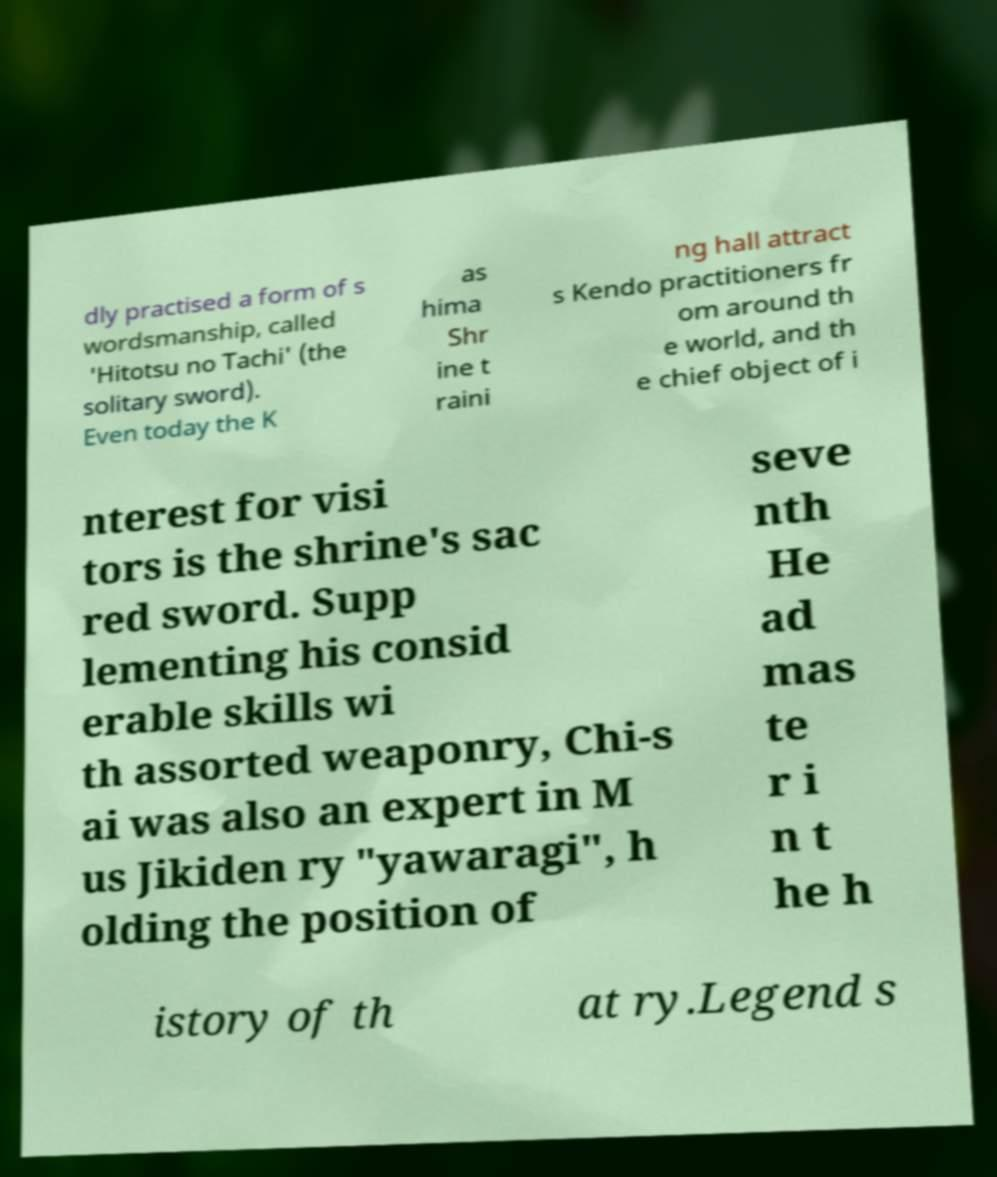Could you assist in decoding the text presented in this image and type it out clearly? dly practised a form of s wordsmanship, called 'Hitotsu no Tachi' (the solitary sword). Even today the K as hima Shr ine t raini ng hall attract s Kendo practitioners fr om around th e world, and th e chief object of i nterest for visi tors is the shrine's sac red sword. Supp lementing his consid erable skills wi th assorted weaponry, Chi-s ai was also an expert in M us Jikiden ry "yawaragi", h olding the position of seve nth He ad mas te r i n t he h istory of th at ry.Legend s 